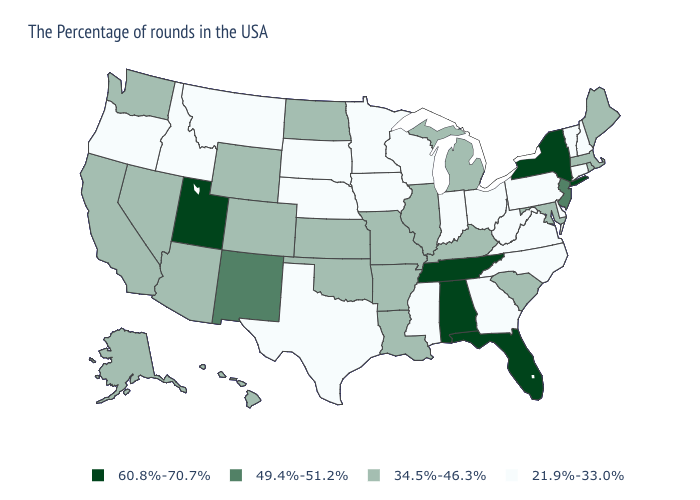Does the first symbol in the legend represent the smallest category?
Answer briefly. No. What is the lowest value in the USA?
Write a very short answer. 21.9%-33.0%. Does Wisconsin have the lowest value in the USA?
Keep it brief. Yes. Does the first symbol in the legend represent the smallest category?
Write a very short answer. No. What is the value of Indiana?
Quick response, please. 21.9%-33.0%. Does South Carolina have a lower value than New Mexico?
Quick response, please. Yes. Name the states that have a value in the range 34.5%-46.3%?
Be succinct. Maine, Massachusetts, Rhode Island, Maryland, South Carolina, Michigan, Kentucky, Illinois, Louisiana, Missouri, Arkansas, Kansas, Oklahoma, North Dakota, Wyoming, Colorado, Arizona, Nevada, California, Washington, Alaska, Hawaii. Name the states that have a value in the range 60.8%-70.7%?
Quick response, please. New York, Florida, Alabama, Tennessee, Utah. Name the states that have a value in the range 21.9%-33.0%?
Answer briefly. New Hampshire, Vermont, Connecticut, Delaware, Pennsylvania, Virginia, North Carolina, West Virginia, Ohio, Georgia, Indiana, Wisconsin, Mississippi, Minnesota, Iowa, Nebraska, Texas, South Dakota, Montana, Idaho, Oregon. Which states have the highest value in the USA?
Answer briefly. New York, Florida, Alabama, Tennessee, Utah. Name the states that have a value in the range 34.5%-46.3%?
Keep it brief. Maine, Massachusetts, Rhode Island, Maryland, South Carolina, Michigan, Kentucky, Illinois, Louisiana, Missouri, Arkansas, Kansas, Oklahoma, North Dakota, Wyoming, Colorado, Arizona, Nevada, California, Washington, Alaska, Hawaii. What is the highest value in the South ?
Keep it brief. 60.8%-70.7%. Which states hav the highest value in the MidWest?
Answer briefly. Michigan, Illinois, Missouri, Kansas, North Dakota. Name the states that have a value in the range 21.9%-33.0%?
Keep it brief. New Hampshire, Vermont, Connecticut, Delaware, Pennsylvania, Virginia, North Carolina, West Virginia, Ohio, Georgia, Indiana, Wisconsin, Mississippi, Minnesota, Iowa, Nebraska, Texas, South Dakota, Montana, Idaho, Oregon. What is the value of Oklahoma?
Give a very brief answer. 34.5%-46.3%. 